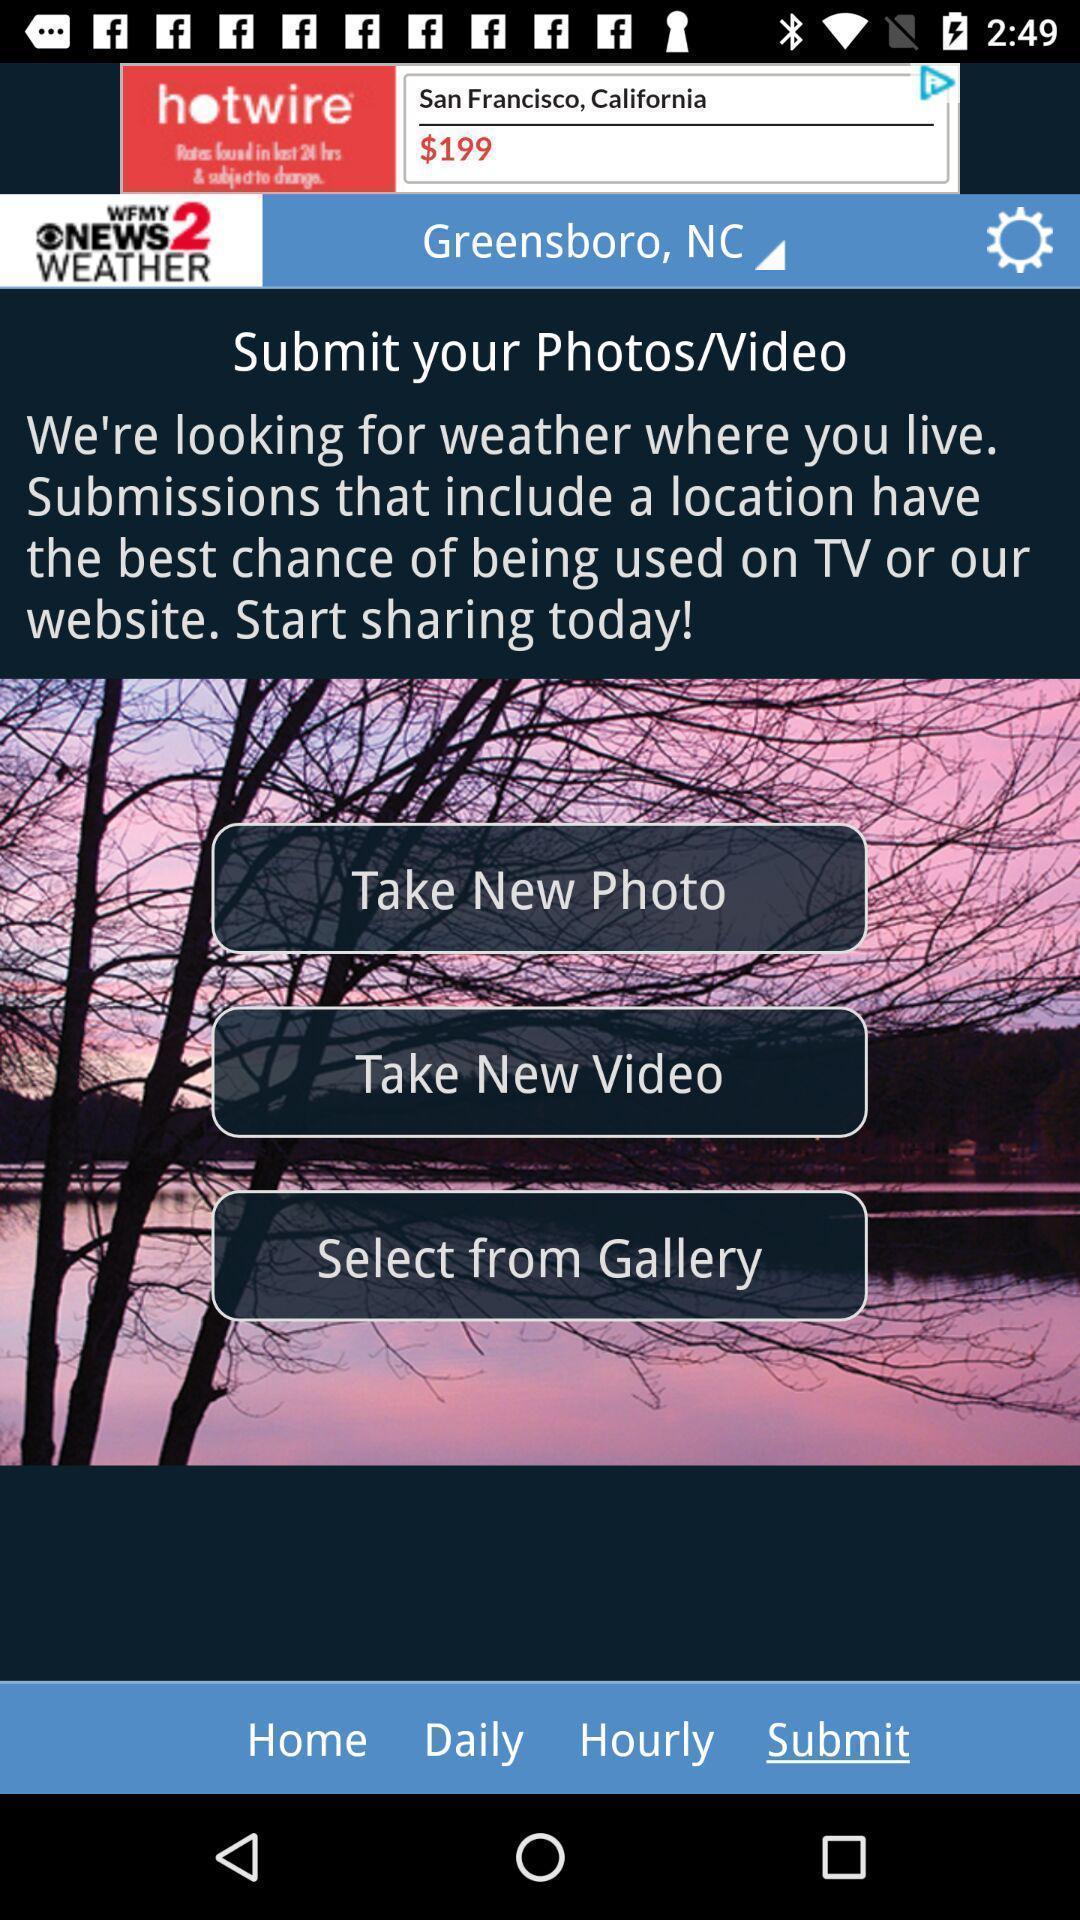Give me a summary of this screen capture. Screen page displaying multiple options in weather application. 